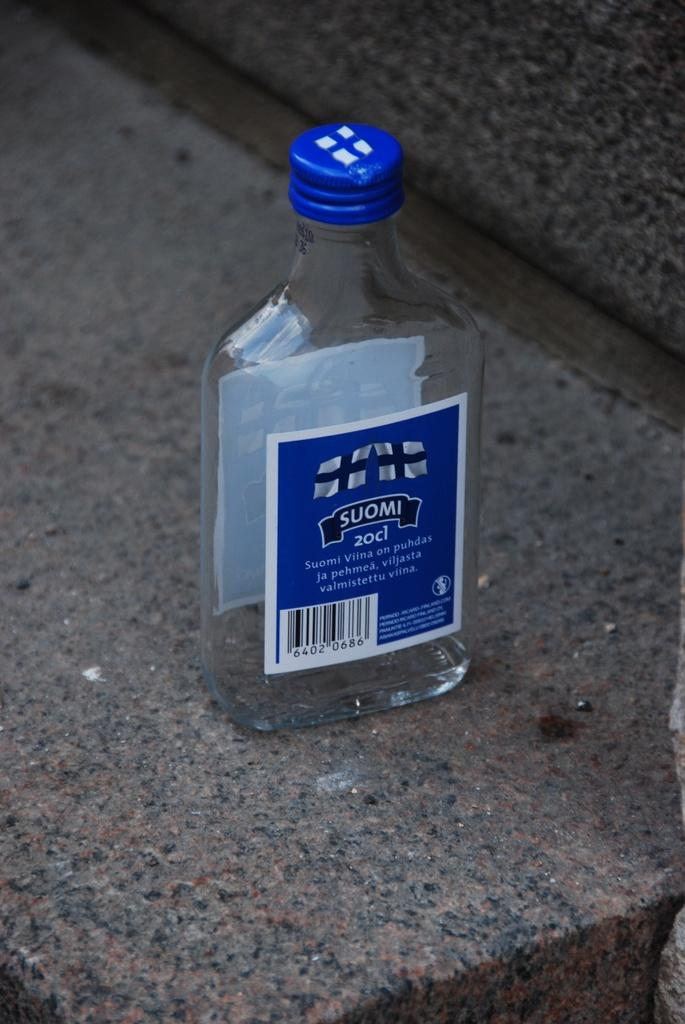<image>
Relay a brief, clear account of the picture shown. a small bottle sitting on stone that is labeled 'suomi 20cl' 